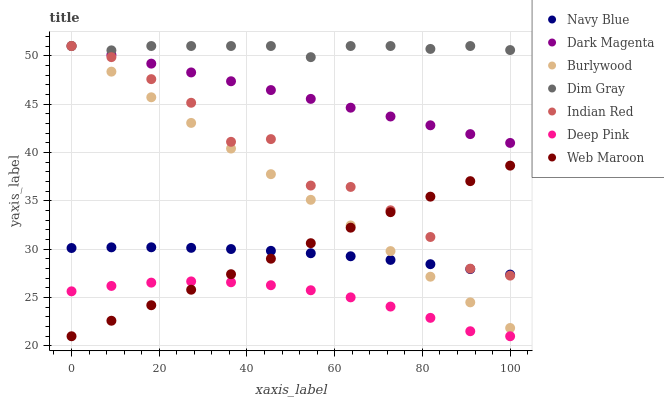Does Deep Pink have the minimum area under the curve?
Answer yes or no. Yes. Does Dim Gray have the maximum area under the curve?
Answer yes or no. Yes. Does Dark Magenta have the minimum area under the curve?
Answer yes or no. No. Does Dark Magenta have the maximum area under the curve?
Answer yes or no. No. Is Web Maroon the smoothest?
Answer yes or no. Yes. Is Indian Red the roughest?
Answer yes or no. Yes. Is Dark Magenta the smoothest?
Answer yes or no. No. Is Dark Magenta the roughest?
Answer yes or no. No. Does Web Maroon have the lowest value?
Answer yes or no. Yes. Does Dark Magenta have the lowest value?
Answer yes or no. No. Does Indian Red have the highest value?
Answer yes or no. Yes. Does Navy Blue have the highest value?
Answer yes or no. No. Is Deep Pink less than Indian Red?
Answer yes or no. Yes. Is Navy Blue greater than Deep Pink?
Answer yes or no. Yes. Does Navy Blue intersect Burlywood?
Answer yes or no. Yes. Is Navy Blue less than Burlywood?
Answer yes or no. No. Is Navy Blue greater than Burlywood?
Answer yes or no. No. Does Deep Pink intersect Indian Red?
Answer yes or no. No. 